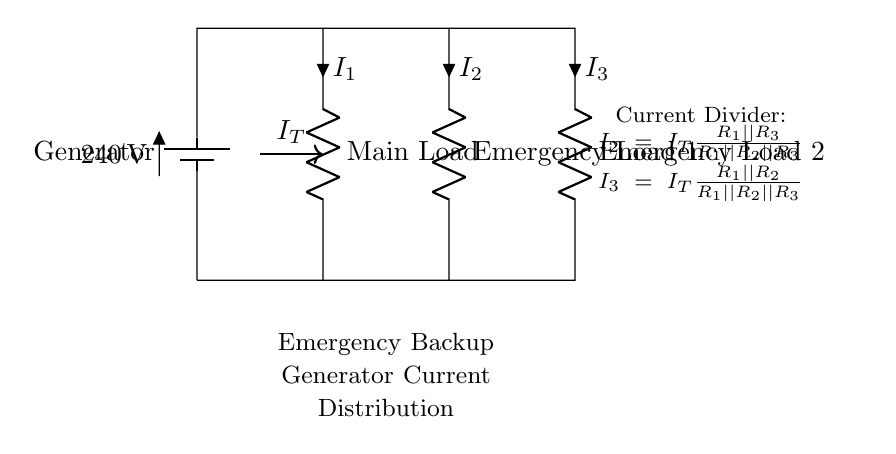What is the voltage provided by the generator? The voltage is listed as 240, which indicates the potential difference supplied by the battery.
Answer: 240 What are the components in this circuit? The components include a battery (generator), a main load resistor, and two emergency load resistors. Each component is identified by its label within the diagram.
Answer: Battery, Main Load, Emergency Load 1, Emergency Load 2 What does the term "current divider" refer to in this circuit? The term "current divider" refers to the function of the circuit that distributes the total current (I_T) among the parallel resistors (emergency loads) based on their resistances.
Answer: Distribution of current What is the total current flowing into the circuit? The total current (I_T) is indicated by the arrow labeled as such between the main load and the generator. This signifies that all branch currents stem from this total current.
Answer: I_T How is the resistance of the loads arranged? The resistors (loads) are arranged in parallel, allowing the total current to split among them based on their respective values. This parallel configuration is crucial in determining the current that each load receives.
Answer: Parallel What are the values of the emergency loads? The emergency loads are labeled as Emergency Load 1 and Emergency Load 2. However, the specific resistance values are not given in the diagram, so they would need to be inferred or provided.
Answer: Not specified 